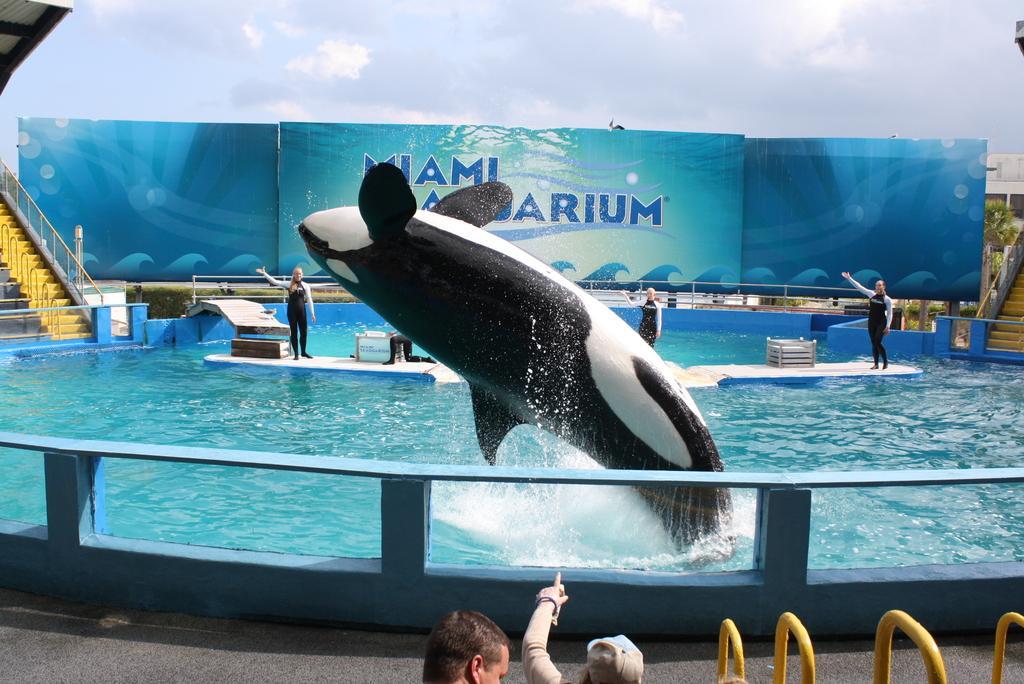How would you summarize this image in a sentence or two? In this image I can see a fish, fence, water and a group of people are standing. In the background I can see staircases, houseplants, hoardings and the sky. This image is taken may be during a day. 